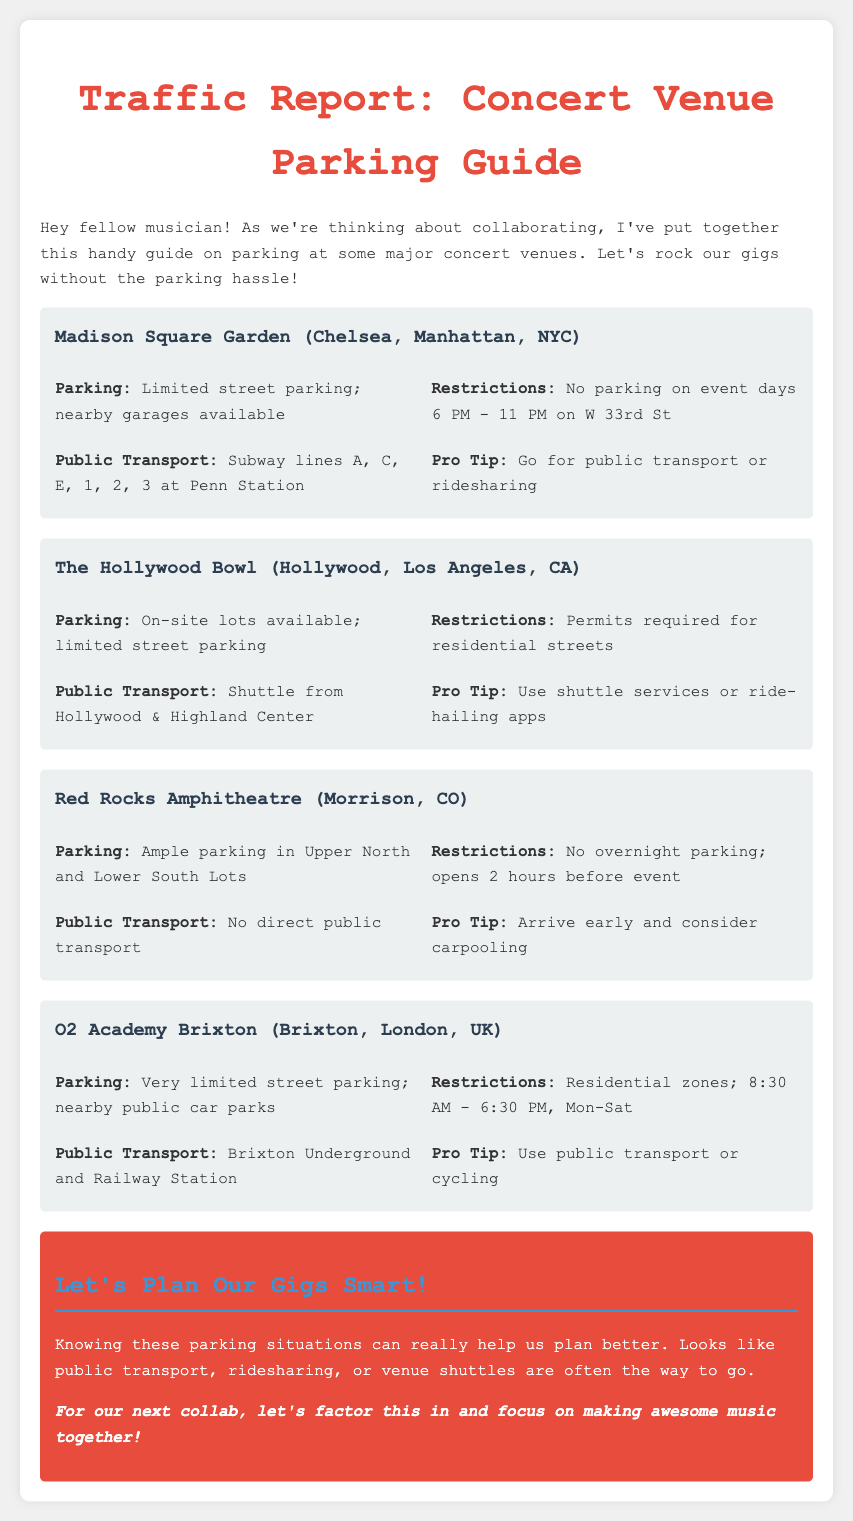What are the parking options at Madison Square Garden? The parking options include limited street parking and nearby garages.
Answer: Limited street parking; nearby garages available What time are parking restrictions enforced at Madison Square Garden? Parking restrictions are enforced on event days from 6 PM to 11 PM on W 33rd St.
Answer: 6 PM - 11 PM Which nearby public transport option is available for The Hollywood Bowl? The public transport option is a shuttle from Hollywood & Highland Center.
Answer: Shuttle from Hollywood & Highland Center Is overnight parking allowed at Red Rocks Amphitheatre? The document mentions that overnight parking is not allowed.
Answer: No overnight parking What is the parking situation at O2 Academy Brixton? The parking situation includes very limited street parking and nearby public car parks.
Answer: Very limited street parking; nearby public car parks What is a recommended pro tip for parking at Red Rocks Amphitheatre? The pro tip suggests arriving early and considering carpooling.
Answer: Arrive early and consider carpooling 